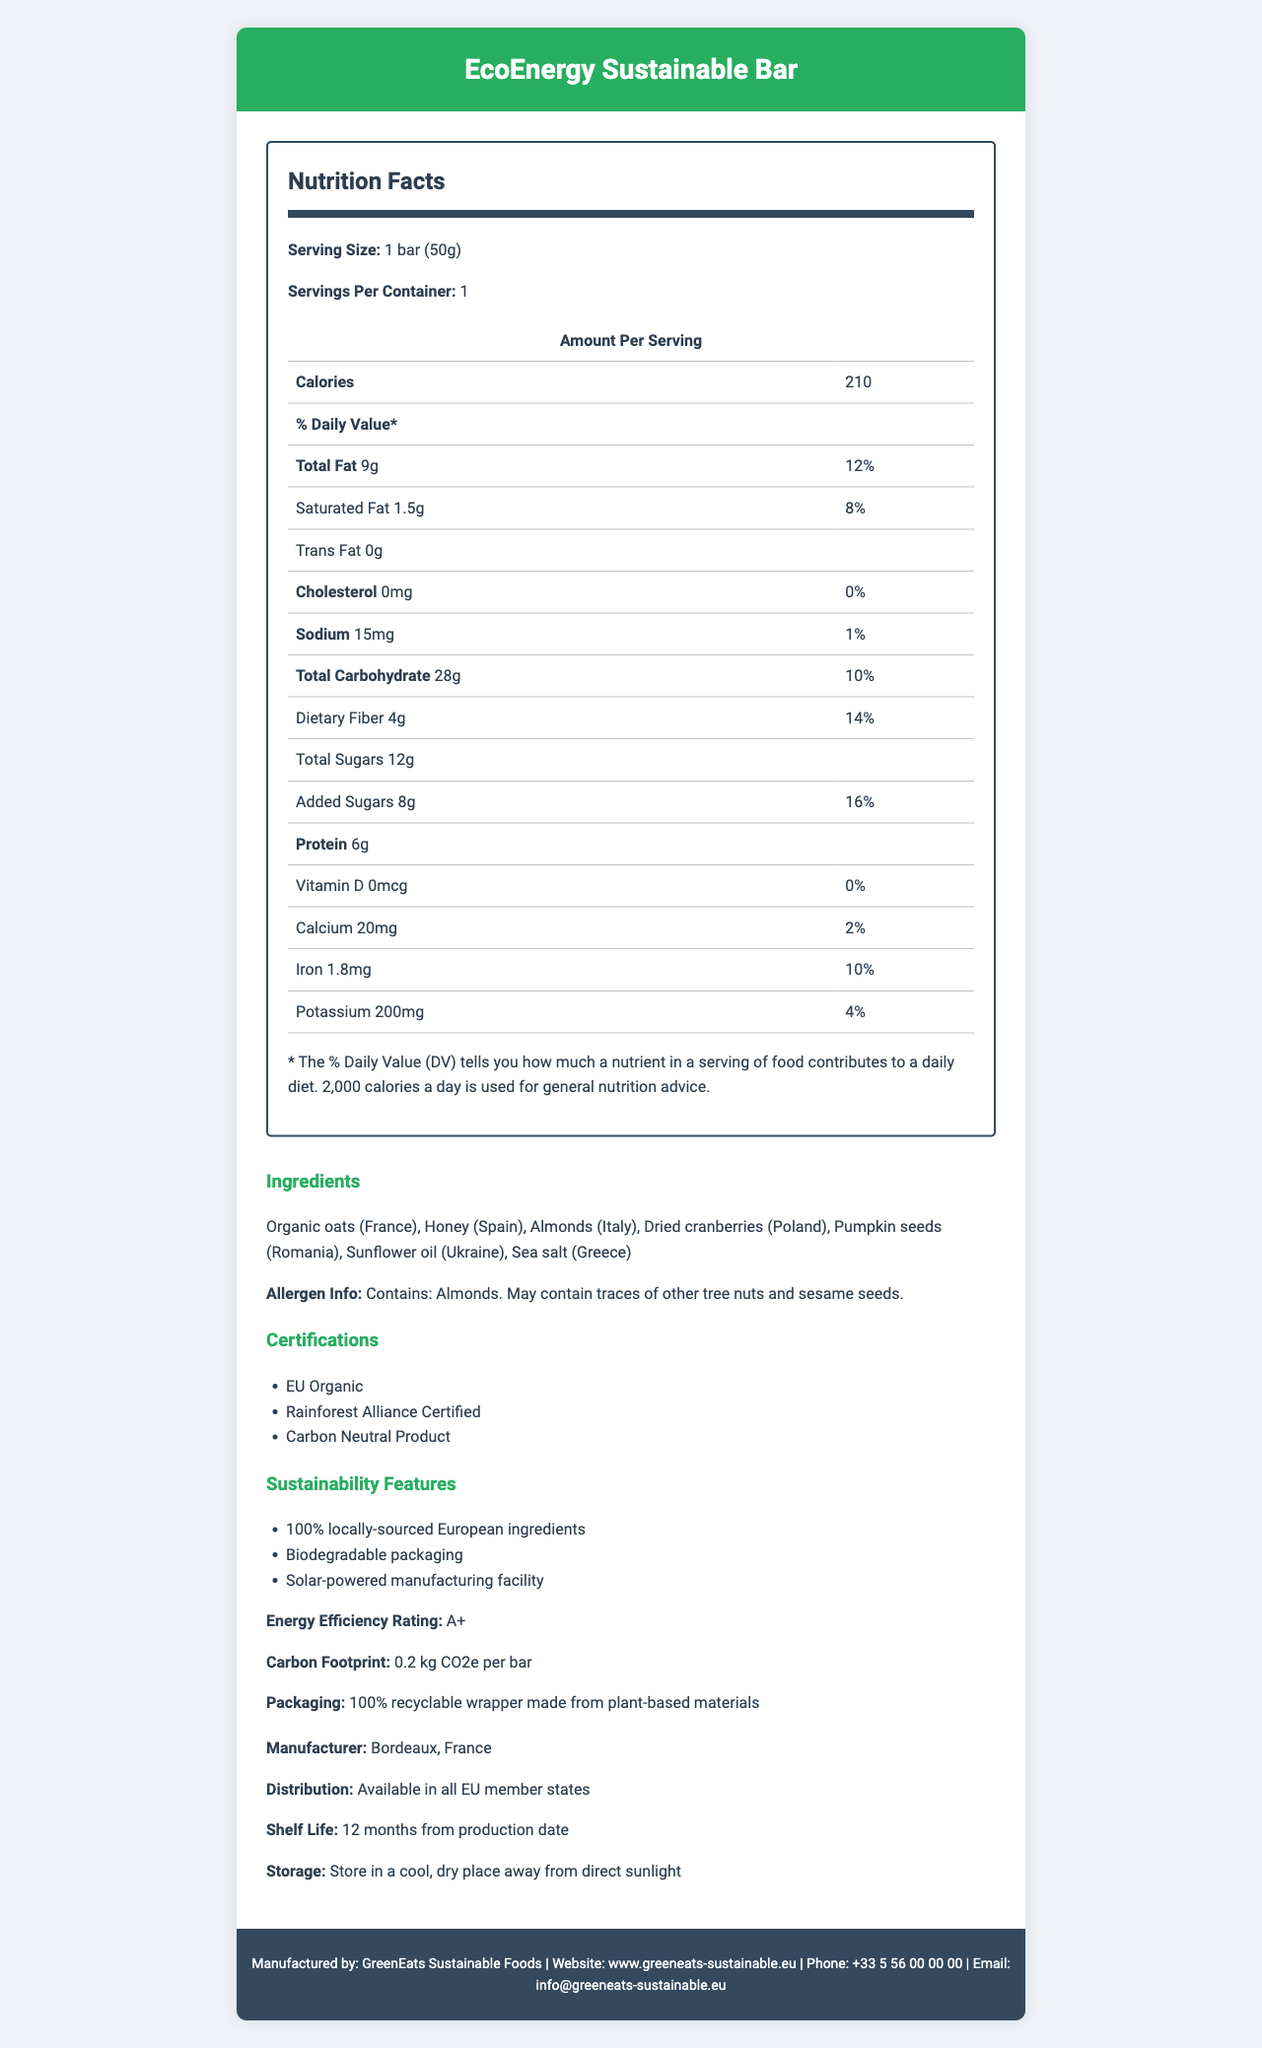what is the serving size of the EcoEnergy Sustainable Bar? The serving size is stated under the Nutrition Facts section: "Serving Size: 1 bar (50g)".
Answer: 1 bar (50g) How much protein does one EcoEnergy Sustainable Bar contain? The amount of protein is listed under the Nutrition Facts: 6g.
Answer: 6g What percentage of the daily value of added sugars does the EcoEnergy Sustainable Bar provide? The percentage is listed under the Nutrition Facts for Added Sugars: 16%.
Answer: 16% What are the locally-sourced ingredients used in the EcoEnergy Sustainable Bar? The list of ingredients provides the sources of each ingredient and indicates they are locally-sourced within Europe.
Answer: Organic oats (France), Honey (Spain), Almonds (Italy), Dried cranberries (Poland), Pumpkin seeds (Romania), Sunflower oil (Ukraine), Sea salt (Greece) Does the EcoEnergy Sustainable Bar contain any cholesterol? The Nutrition Facts state "Cholesterol: 0mg".
Answer: No What certifications does the EcoEnergy Sustainable Bar have? The certifications are listed in a section under Certifications.
Answer: EU Organic, Rainforest Alliance Certified, Carbon Neutral Product Which of the following is a sustainability feature of the EcoEnergy Sustainable Bar? 
A. 100% recycled packaging 
B. 100% locally-sourced European ingredients 
C. Animal-free ingredients The document states "100% locally-sourced European ingredients" as one of the sustainability features.
Answer: B What is the energy efficiency rating of the EcoEnergy Sustainable Bar? 
A. A 
B. A+ 
C. B 
D. C The energy efficiency rating mentioned is "A+".
Answer: B Does the EcoEnergy Sustainable Bar contain Vitamin D? The Nutrition Facts list Vitamin D as "0mcg".
Answer: No Summarize the main nutritional and sustainability features of the EcoEnergy Sustainable Bar. The document combines nutritional information and emphasizes the sustainable and organic nature of the product, highlighting benefits both for consumers and the environment.
Answer: The EcoEnergy Sustainable Bar provides a mix of nutrients including 210 calories, 6g of protein, and 12% daily value of total fat per serving. It is rich in locally-sourced European ingredients and certified by EU Organic and Rainforest Alliance. The product is carbon-neutral, uses biodegradable packaging, and is produced in a solar-powered facility. What percentage of daily value for iron does the EcoEnergy Sustainable Bar provide? The percentage daily value for iron is listed as 10% in the Nutrition Facts.
Answer: 10% Where is the EcoEnergy Sustainable Bar manufactured? The document specifies "Manufacturer Location: Bordeaux, France."
Answer: Bordeaux, France What is the total fat content in one serving of the EcoEnergy Sustainable Bar? The total fat content per serving is listed as 9g in the Nutrition Facts.
Answer: 9g Is the packaging for the EcoEnergy Sustainable Bar recyclable? The document states it has "100% recyclable wrapper made from plant-based materials".
Answer: Yes What is the total carbohydrate content in one serving of the EcoEnergy Sustainable Bar? 
A. 28g 
B. 24g 
C. 30g 
D. 20g The total carbohydrate content is listed as 28g in the Nutrition Facts.
Answer: A Can we determine the exact percentage of daily value for total sugars in the EcoEnergy Sustainable Bar? The document provides the percentage daily value only for added sugars, not for total sugars.
Answer: Cannot be determined 